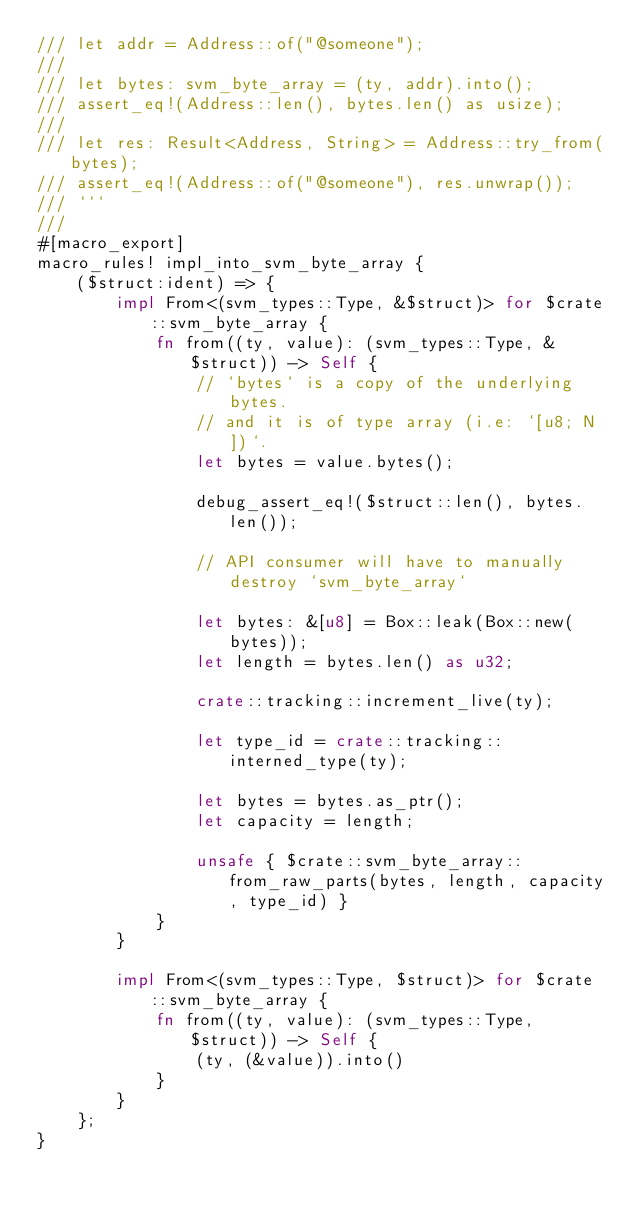<code> <loc_0><loc_0><loc_500><loc_500><_Rust_>/// let addr = Address::of("@someone");
///
/// let bytes: svm_byte_array = (ty, addr).into();
/// assert_eq!(Address::len(), bytes.len() as usize);
///
/// let res: Result<Address, String> = Address::try_from(bytes);
/// assert_eq!(Address::of("@someone"), res.unwrap());
/// ```
///
#[macro_export]
macro_rules! impl_into_svm_byte_array {
    ($struct:ident) => {
        impl From<(svm_types::Type, &$struct)> for $crate::svm_byte_array {
            fn from((ty, value): (svm_types::Type, &$struct)) -> Self {
                // `bytes` is a copy of the underlying bytes.
                // and it is of type array (i.e: `[u8; N])`.
                let bytes = value.bytes();

                debug_assert_eq!($struct::len(), bytes.len());

                // API consumer will have to manually destroy `svm_byte_array`

                let bytes: &[u8] = Box::leak(Box::new(bytes));
                let length = bytes.len() as u32;

                crate::tracking::increment_live(ty);

                let type_id = crate::tracking::interned_type(ty);

                let bytes = bytes.as_ptr();
                let capacity = length;

                unsafe { $crate::svm_byte_array::from_raw_parts(bytes, length, capacity, type_id) }
            }
        }

        impl From<(svm_types::Type, $struct)> for $crate::svm_byte_array {
            fn from((ty, value): (svm_types::Type, $struct)) -> Self {
                (ty, (&value)).into()
            }
        }
    };
}
</code> 